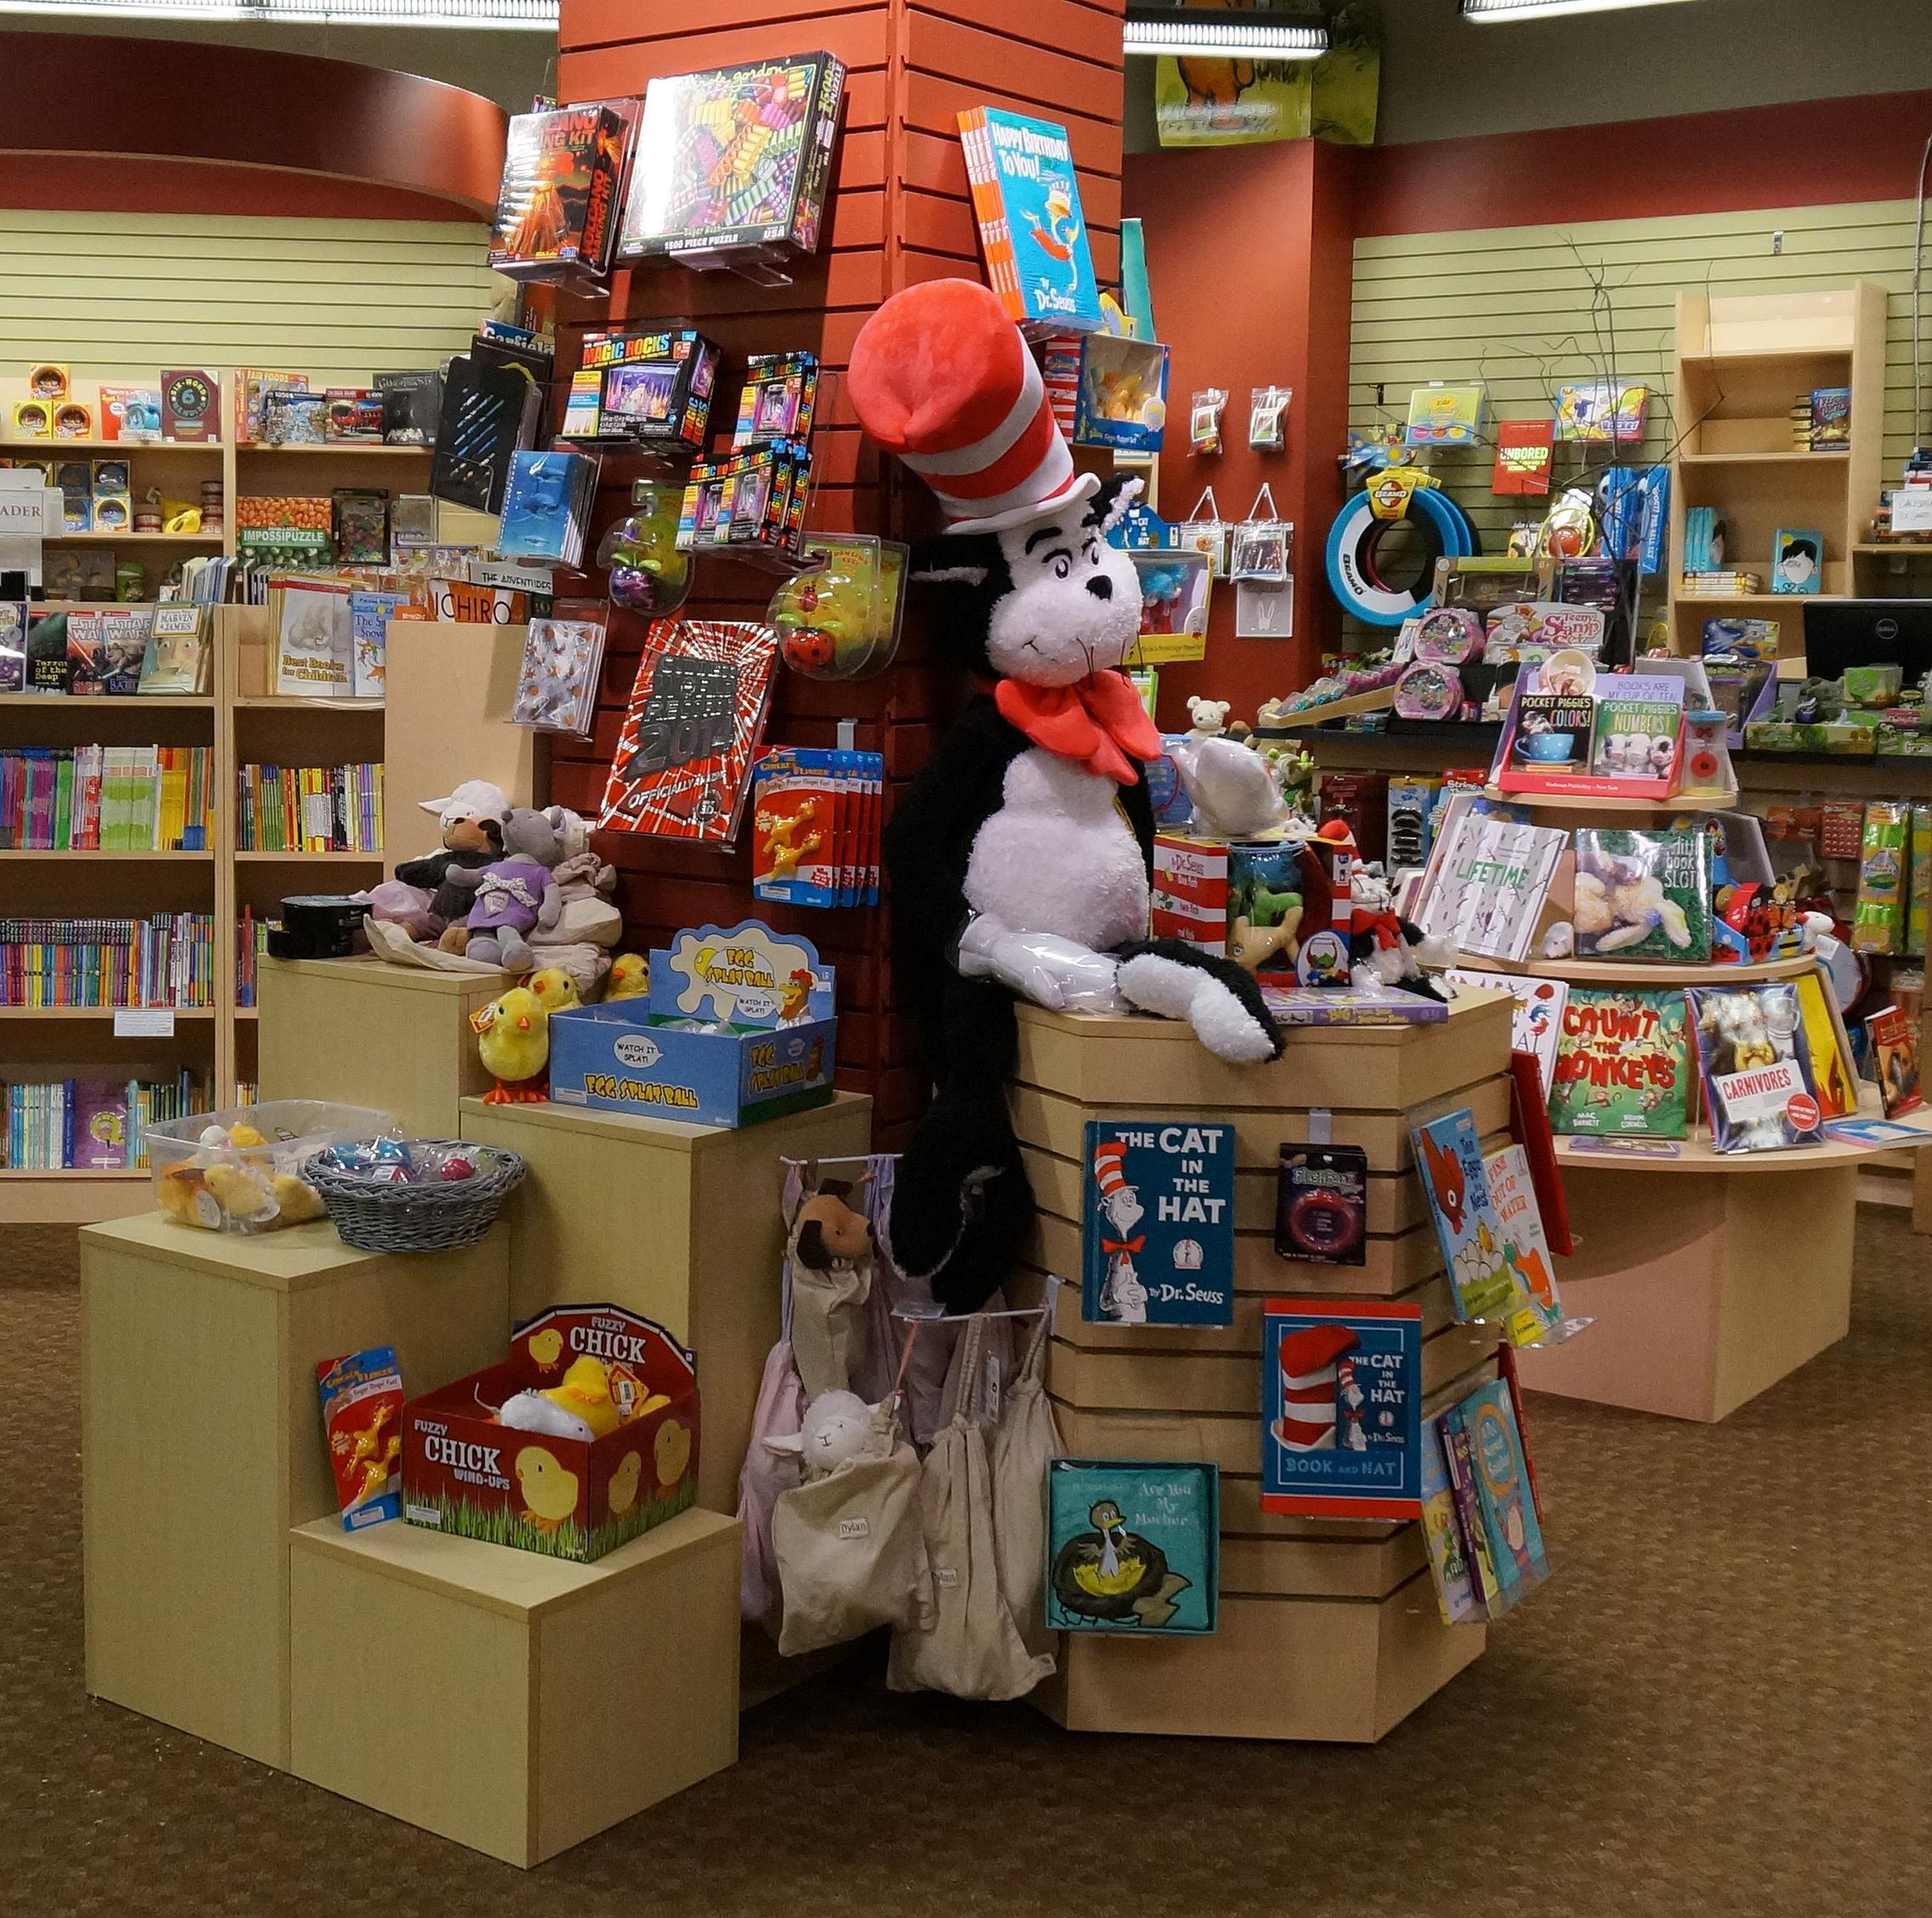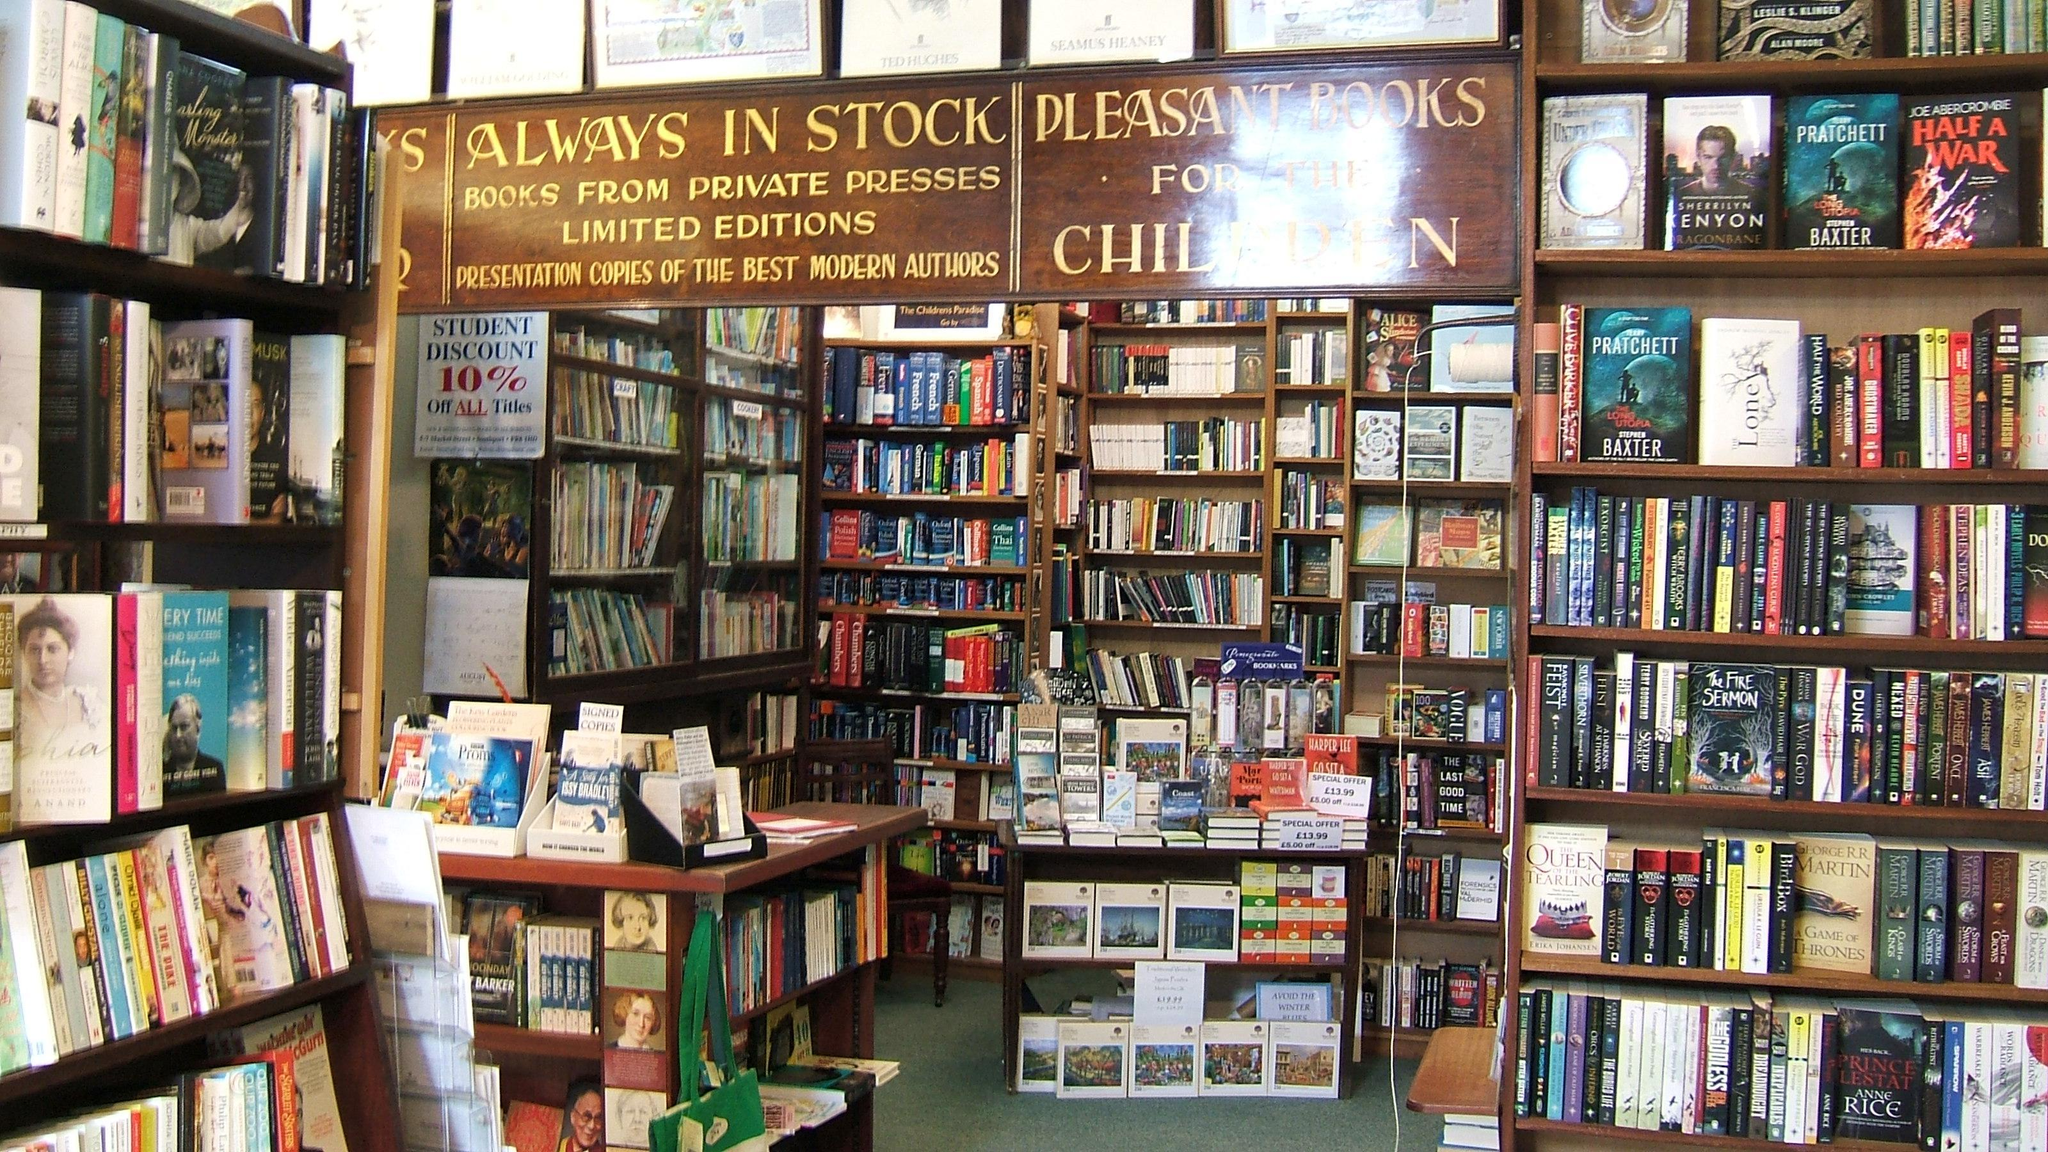The first image is the image on the left, the second image is the image on the right. For the images displayed, is the sentence "One image shows an upright furry cartoonish creature in front of items displayed for sale." factually correct? Answer yes or no. Yes. The first image is the image on the left, the second image is the image on the right. For the images displayed, is the sentence "One of the images features a large stuffed animal/character from a popular book." factually correct? Answer yes or no. Yes. 